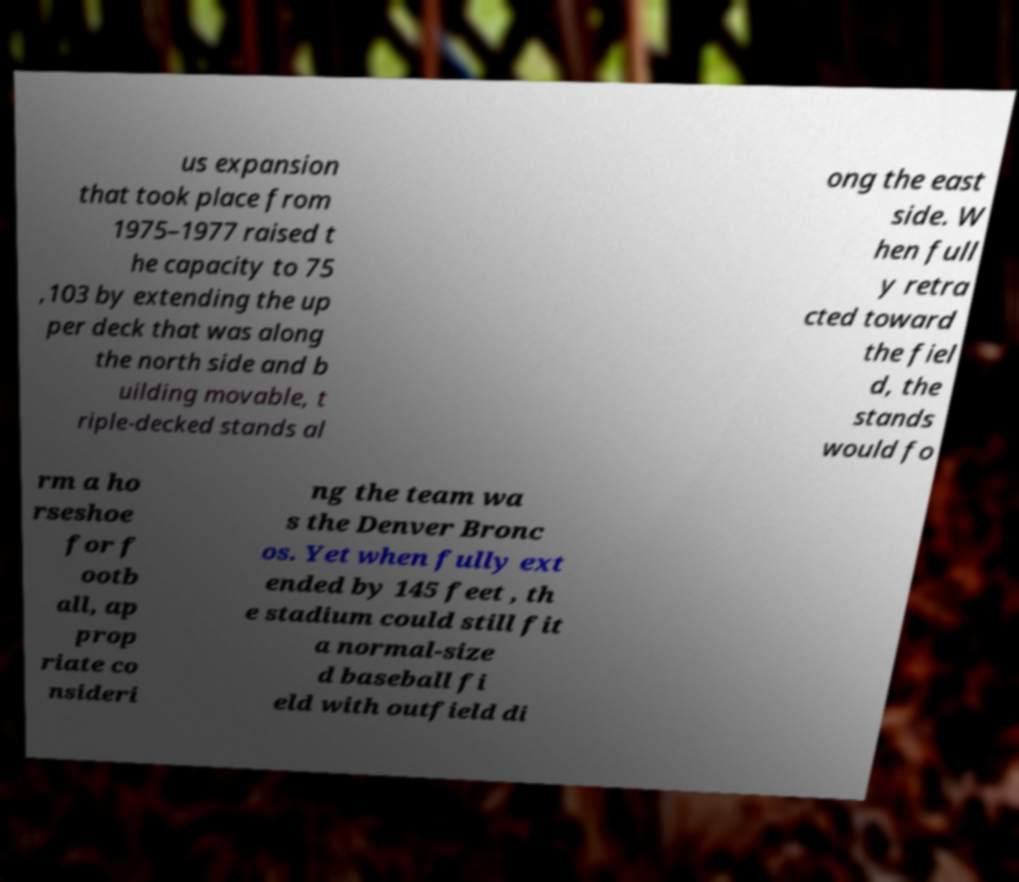There's text embedded in this image that I need extracted. Can you transcribe it verbatim? us expansion that took place from 1975–1977 raised t he capacity to 75 ,103 by extending the up per deck that was along the north side and b uilding movable, t riple-decked stands al ong the east side. W hen full y retra cted toward the fiel d, the stands would fo rm a ho rseshoe for f ootb all, ap prop riate co nsideri ng the team wa s the Denver Bronc os. Yet when fully ext ended by 145 feet , th e stadium could still fit a normal-size d baseball fi eld with outfield di 